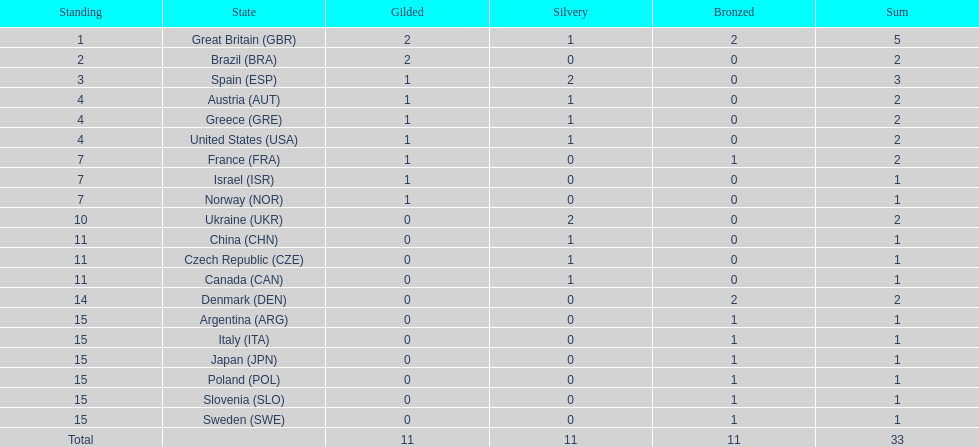Would you mind parsing the complete table? {'header': ['Standing', 'State', 'Gilded', 'Silvery', 'Bronzed', 'Sum'], 'rows': [['1', 'Great Britain\xa0(GBR)', '2', '1', '2', '5'], ['2', 'Brazil\xa0(BRA)', '2', '0', '0', '2'], ['3', 'Spain\xa0(ESP)', '1', '2', '0', '3'], ['4', 'Austria\xa0(AUT)', '1', '1', '0', '2'], ['4', 'Greece\xa0(GRE)', '1', '1', '0', '2'], ['4', 'United States\xa0(USA)', '1', '1', '0', '2'], ['7', 'France\xa0(FRA)', '1', '0', '1', '2'], ['7', 'Israel\xa0(ISR)', '1', '0', '0', '1'], ['7', 'Norway\xa0(NOR)', '1', '0', '0', '1'], ['10', 'Ukraine\xa0(UKR)', '0', '2', '0', '2'], ['11', 'China\xa0(CHN)', '0', '1', '0', '1'], ['11', 'Czech Republic\xa0(CZE)', '0', '1', '0', '1'], ['11', 'Canada\xa0(CAN)', '0', '1', '0', '1'], ['14', 'Denmark\xa0(DEN)', '0', '0', '2', '2'], ['15', 'Argentina\xa0(ARG)', '0', '0', '1', '1'], ['15', 'Italy\xa0(ITA)', '0', '0', '1', '1'], ['15', 'Japan\xa0(JPN)', '0', '0', '1', '1'], ['15', 'Poland\xa0(POL)', '0', '0', '1', '1'], ['15', 'Slovenia\xa0(SLO)', '0', '0', '1', '1'], ['15', 'Sweden\xa0(SWE)', '0', '0', '1', '1'], ['Total', '', '11', '11', '11', '33']]} Which country won the most medals total? Great Britain (GBR). 